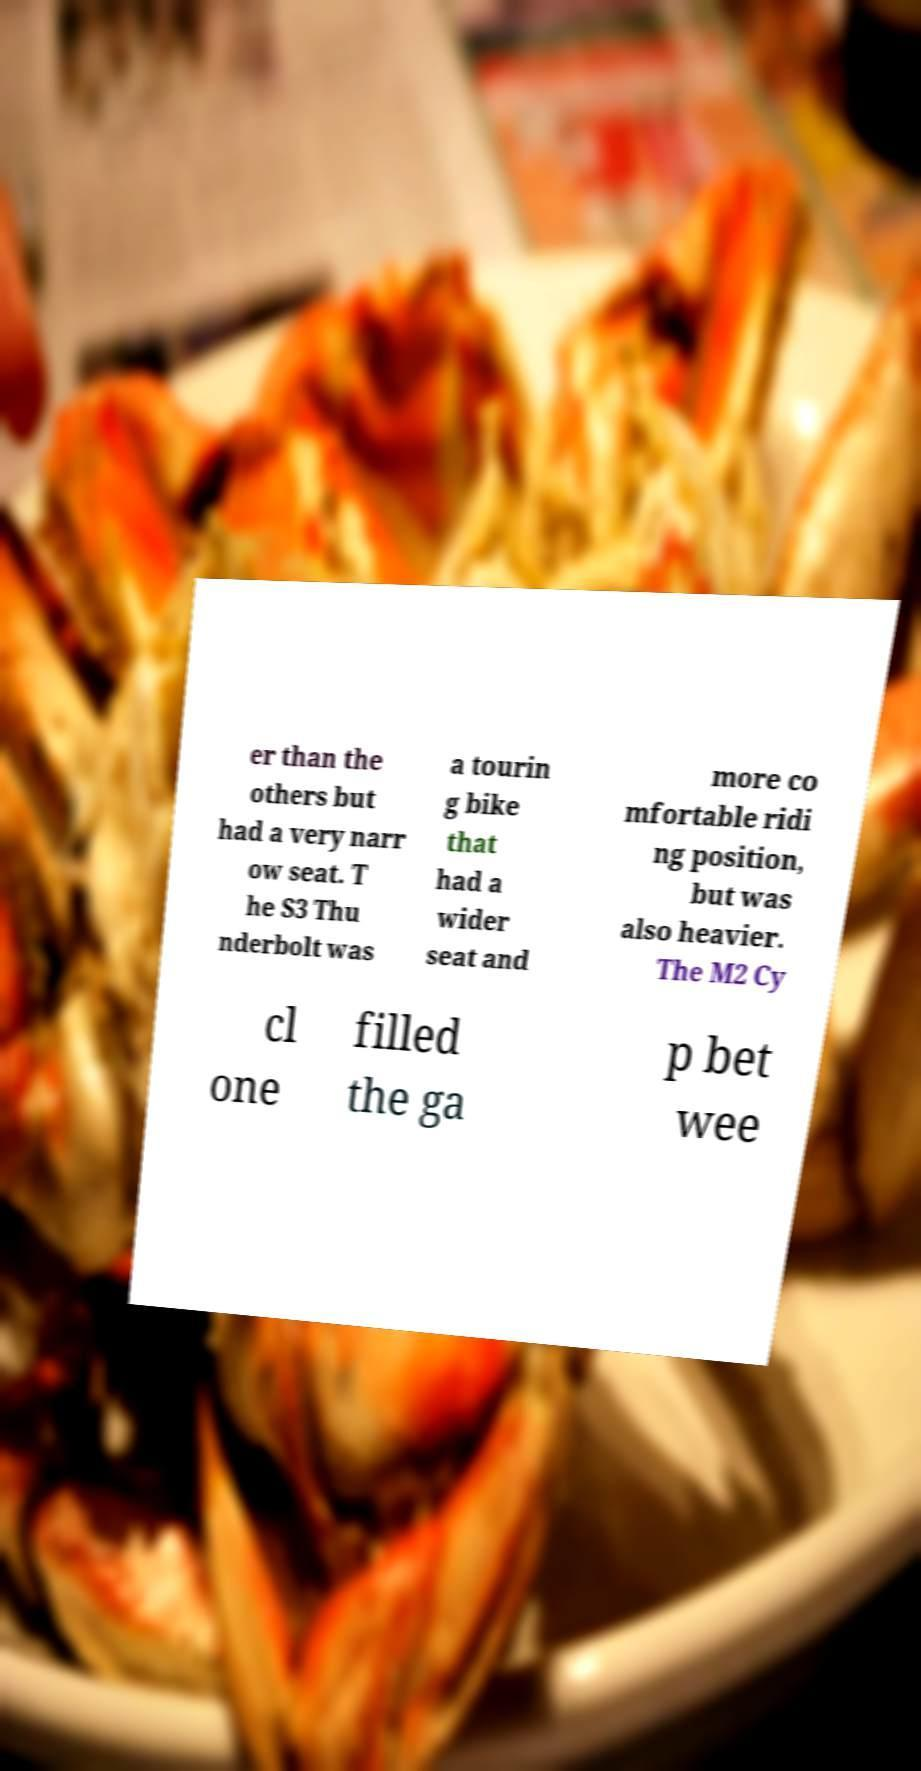Can you read and provide the text displayed in the image?This photo seems to have some interesting text. Can you extract and type it out for me? er than the others but had a very narr ow seat. T he S3 Thu nderbolt was a tourin g bike that had a wider seat and more co mfortable ridi ng position, but was also heavier. The M2 Cy cl one filled the ga p bet wee 